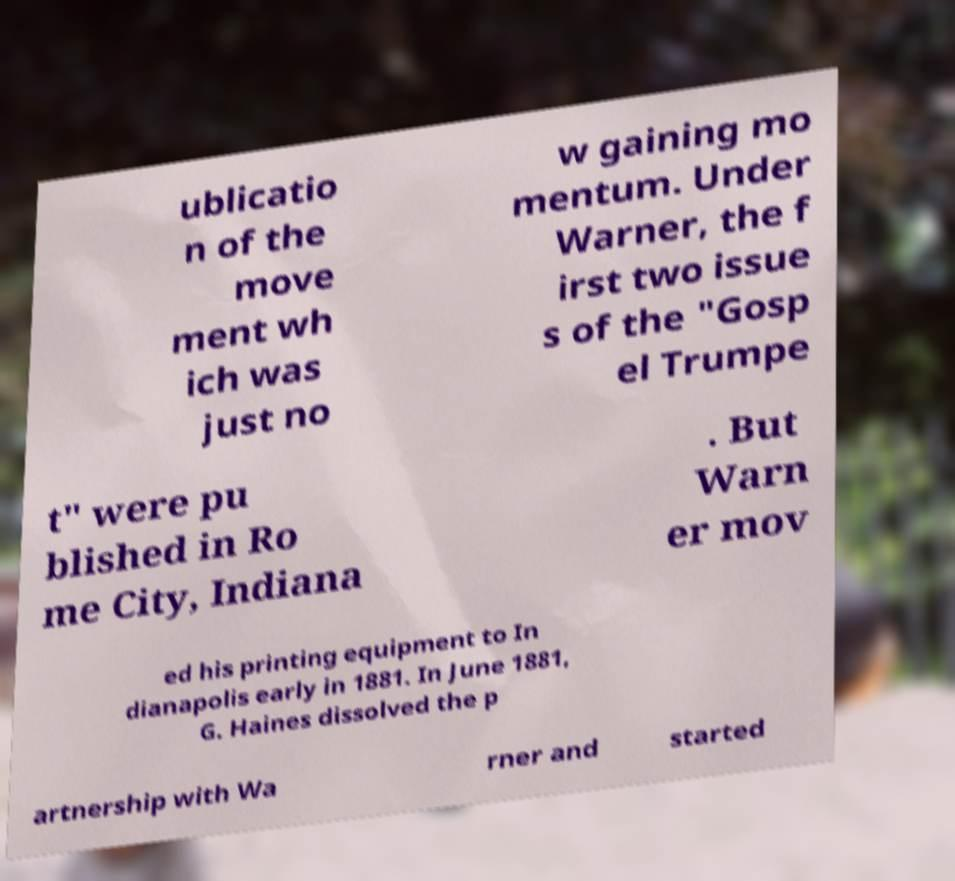I need the written content from this picture converted into text. Can you do that? ublicatio n of the move ment wh ich was just no w gaining mo mentum. Under Warner, the f irst two issue s of the "Gosp el Trumpe t" were pu blished in Ro me City, Indiana . But Warn er mov ed his printing equipment to In dianapolis early in 1881. In June 1881, G. Haines dissolved the p artnership with Wa rner and started 